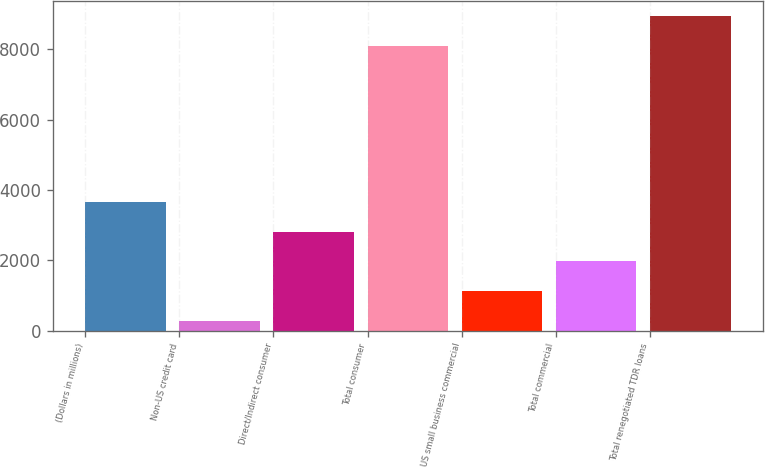<chart> <loc_0><loc_0><loc_500><loc_500><bar_chart><fcel>(Dollars in millions)<fcel>Non-US credit card<fcel>Direct/Indirect consumer<fcel>Total consumer<fcel>US small business commercial<fcel>Total commercial<fcel>Total renegotiated TDR loans<nl><fcel>3657.2<fcel>282<fcel>2813.4<fcel>8096<fcel>1125.8<fcel>1969.6<fcel>8939.8<nl></chart> 